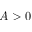<formula> <loc_0><loc_0><loc_500><loc_500>A > 0</formula> 